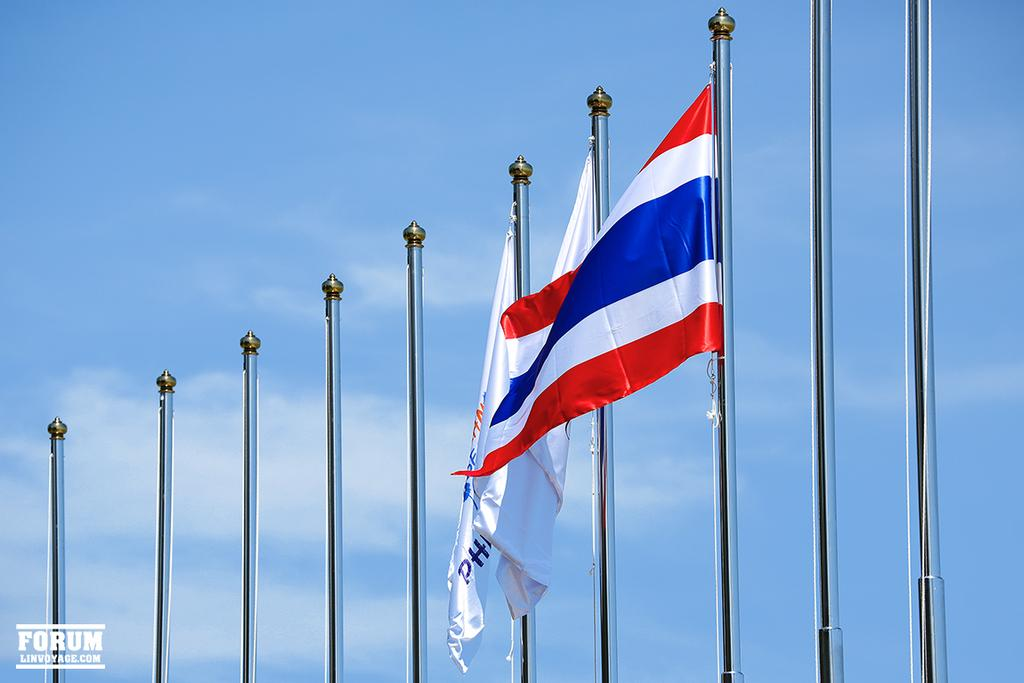Where was the image taken? The image is taken outdoors. What can be seen in the background of the image? There is the sky with clouds in the background. What is the main subject in the middle of the image? There are many flag poles in the middle of the image. How many flags are visible on the flag poles? There are three flags on the flag poles. Who is the manager of the selection process for the flags in the image? There is no information about a manager or a selection process for the flags in the image. 